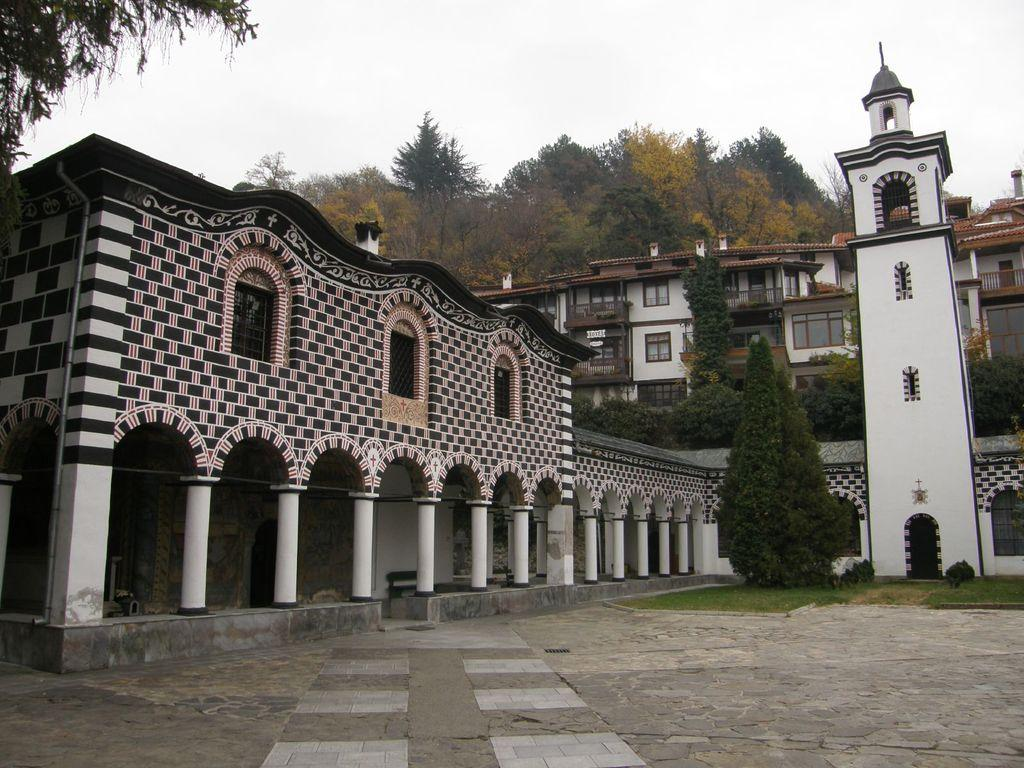What is located in the center of the image? There are trees and buildings in the center of the image. What is the condition of the sky in the image? The sky is cloudy in the image. What type of ground surface is visible in the foreground of the image? There are cobblestones in the foreground of the image. How many fingers can be seen holding a kitten during a protest in the image? There is no protest, kitten, or fingers holding a kitten present in the image. 